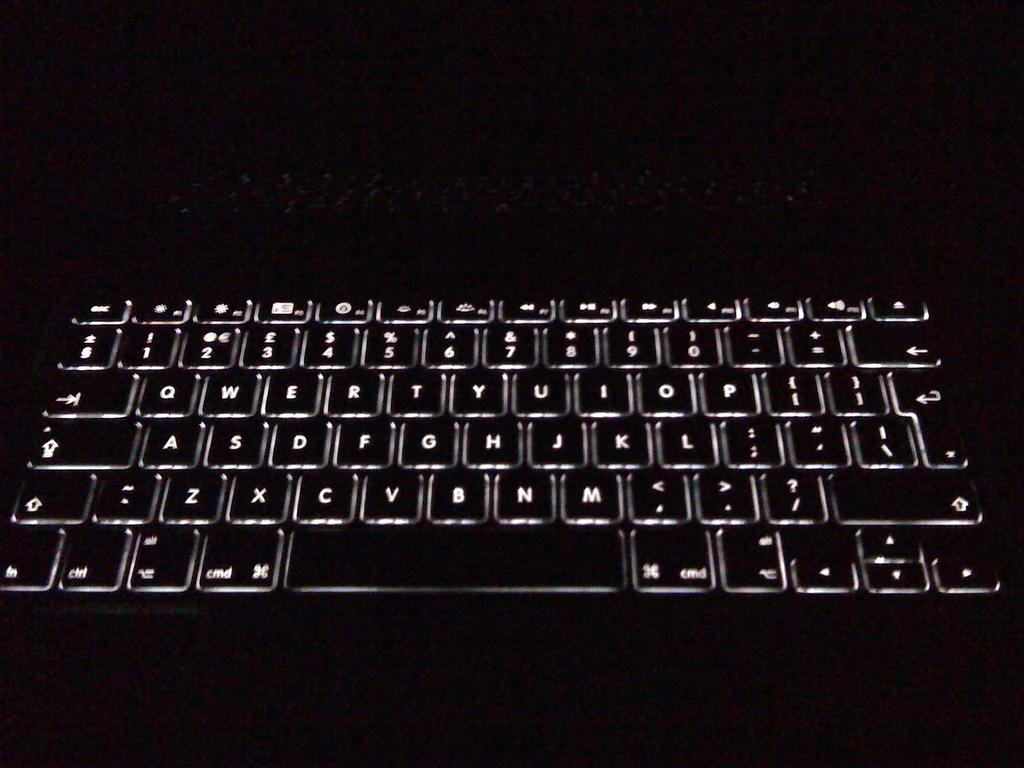Provide a one-sentence caption for the provided image. A lit up keyboard in the dark that has a 'cmd' button on it. 